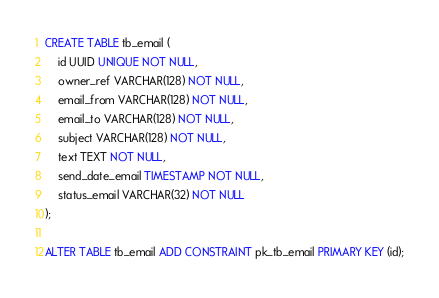Convert code to text. <code><loc_0><loc_0><loc_500><loc_500><_SQL_>CREATE TABLE tb_email (
    id UUID UNIQUE NOT NULL,
    owner_ref VARCHAR(128) NOT NULL,
    email_from VARCHAR(128) NOT NULL,
    email_to VARCHAR(128) NOT NULL,
    subject VARCHAR(128) NOT NULL,
    text TEXT NOT NULL,
    send_date_email TIMESTAMP NOT NULL,
    status_email VARCHAR(32) NOT NULL
);

ALTER TABLE tb_email ADD CONSTRAINT pk_tb_email PRIMARY KEY (id);</code> 